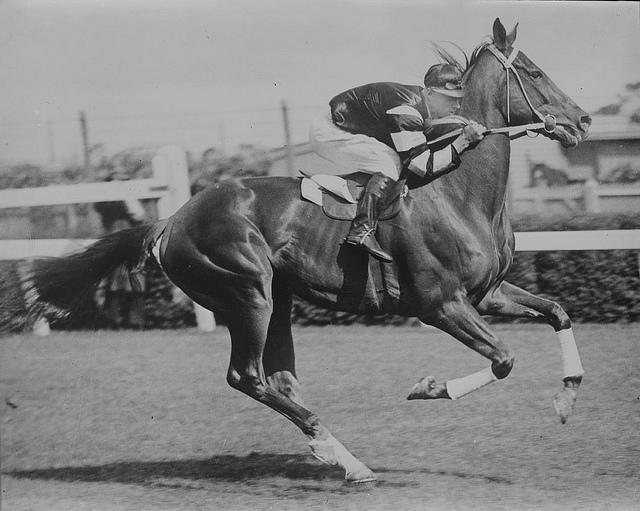What sport is being shown?
Short answer required. Horse racing. Is this a recent photo?
Quick response, please. No. Is the image in black and white?
Keep it brief. Yes. Which animal has been carried?
Short answer required. Horse. 